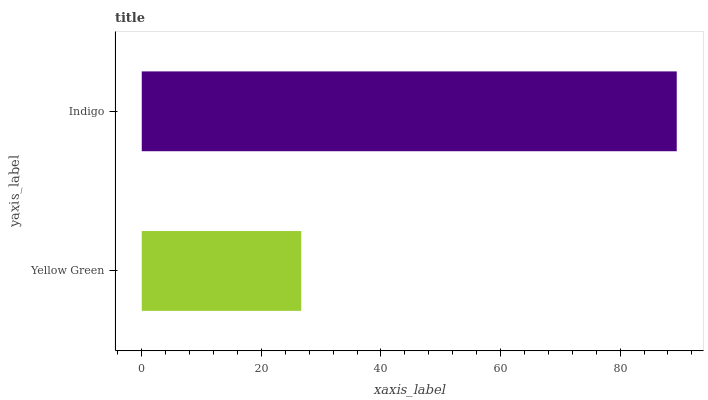Is Yellow Green the minimum?
Answer yes or no. Yes. Is Indigo the maximum?
Answer yes or no. Yes. Is Indigo the minimum?
Answer yes or no. No. Is Indigo greater than Yellow Green?
Answer yes or no. Yes. Is Yellow Green less than Indigo?
Answer yes or no. Yes. Is Yellow Green greater than Indigo?
Answer yes or no. No. Is Indigo less than Yellow Green?
Answer yes or no. No. Is Indigo the high median?
Answer yes or no. Yes. Is Yellow Green the low median?
Answer yes or no. Yes. Is Yellow Green the high median?
Answer yes or no. No. Is Indigo the low median?
Answer yes or no. No. 